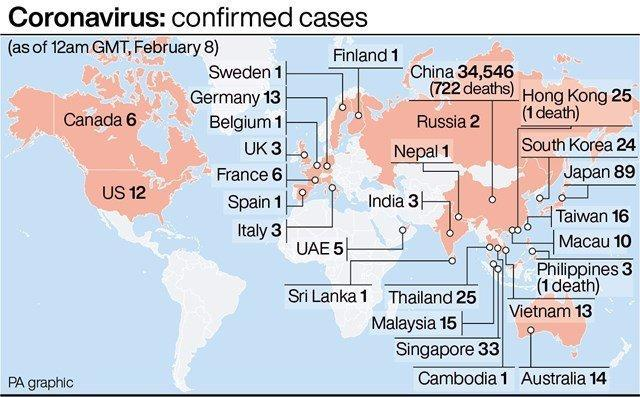How many confirmed cases of COVID-19 were reported in South Korea as of February 8?
Answer the question with a short phrase. 24 Which country has reported the highest number of COVID-19 cases globally as of February 8? China Which country has reported the highest number of fatalities due to COVID-19 as of February 8? China What is the number of fatalities due to COVID-19 in Philippines as of February 8? 1 How many confirmed cases of COVID-19 were reported in Singapore as of February 8? 33 Which country has reported the second highest number of COVID-19 cases globally as of February 8? Japan What is the number of fatalities due to COVID-19 in Hong kong as of February 8? 1 